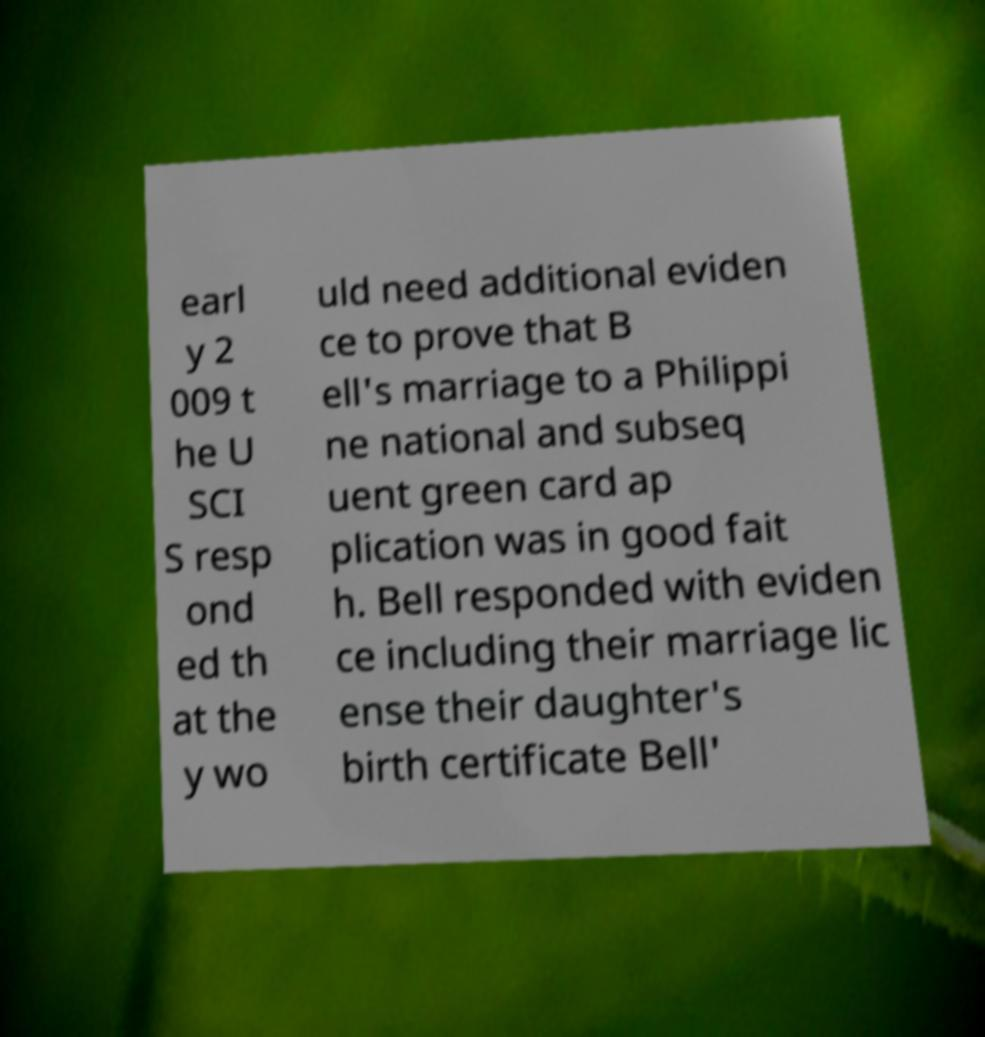Can you accurately transcribe the text from the provided image for me? earl y 2 009 t he U SCI S resp ond ed th at the y wo uld need additional eviden ce to prove that B ell's marriage to a Philippi ne national and subseq uent green card ap plication was in good fait h. Bell responded with eviden ce including their marriage lic ense their daughter's birth certificate Bell' 